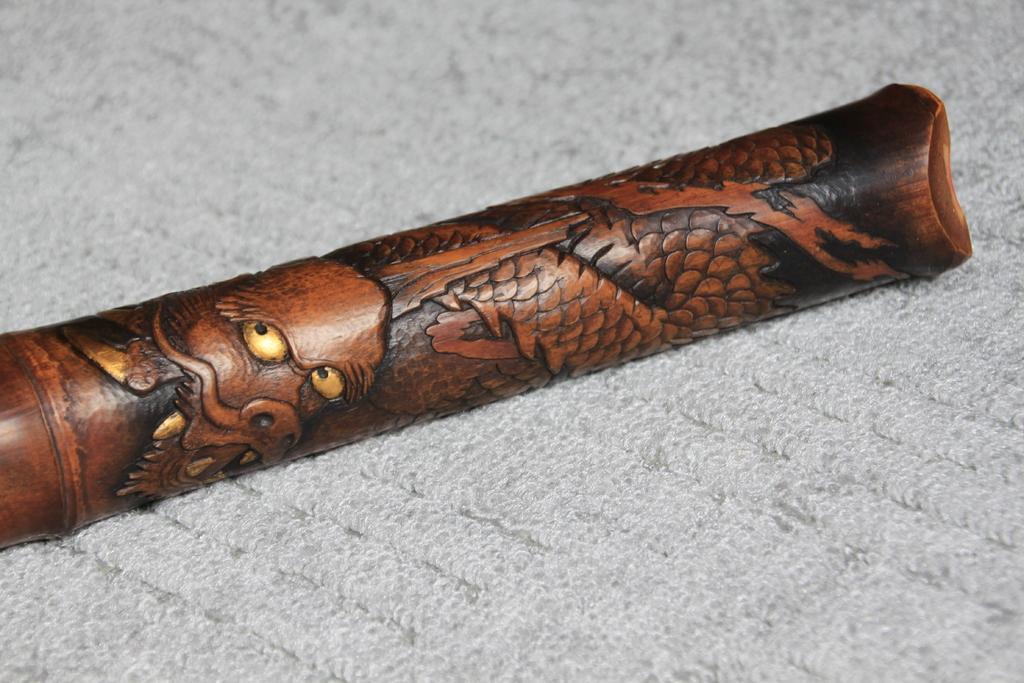Can you describe this image briefly? In the center of the image we can see rifle placed on the cloth. 